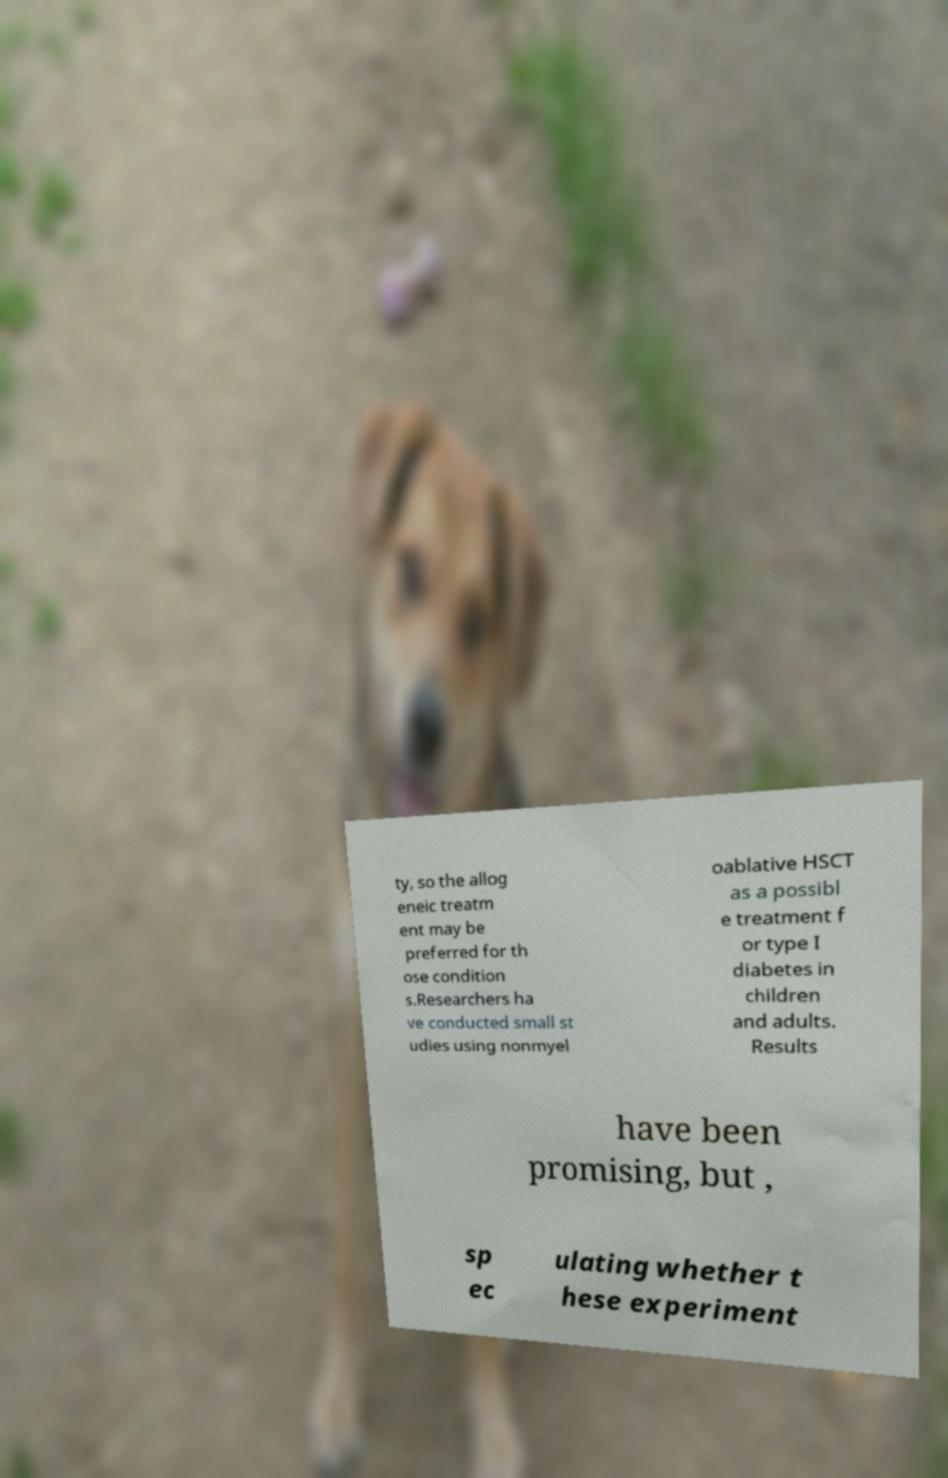Could you assist in decoding the text presented in this image and type it out clearly? ty, so the allog eneic treatm ent may be preferred for th ose condition s.Researchers ha ve conducted small st udies using nonmyel oablative HSCT as a possibl e treatment f or type I diabetes in children and adults. Results have been promising, but , sp ec ulating whether t hese experiment 